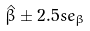<formula> <loc_0><loc_0><loc_500><loc_500>\hat { \beta } \pm 2 . 5 s e _ { \beta }</formula> 